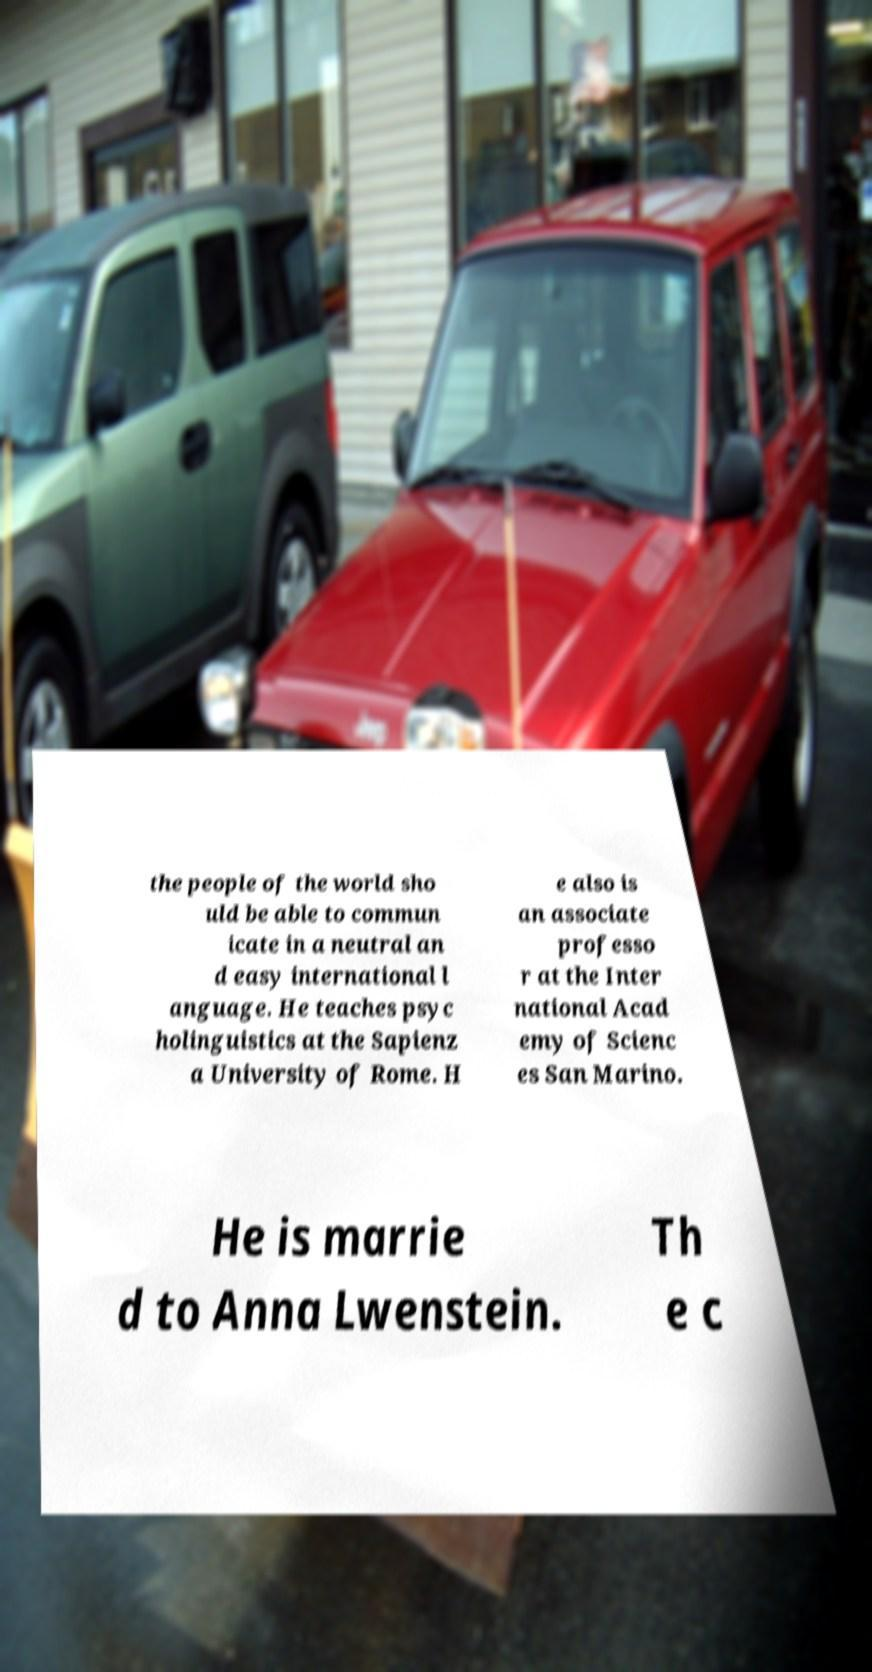For documentation purposes, I need the text within this image transcribed. Could you provide that? the people of the world sho uld be able to commun icate in a neutral an d easy international l anguage. He teaches psyc holinguistics at the Sapienz a University of Rome. H e also is an associate professo r at the Inter national Acad emy of Scienc es San Marino. He is marrie d to Anna Lwenstein. Th e c 